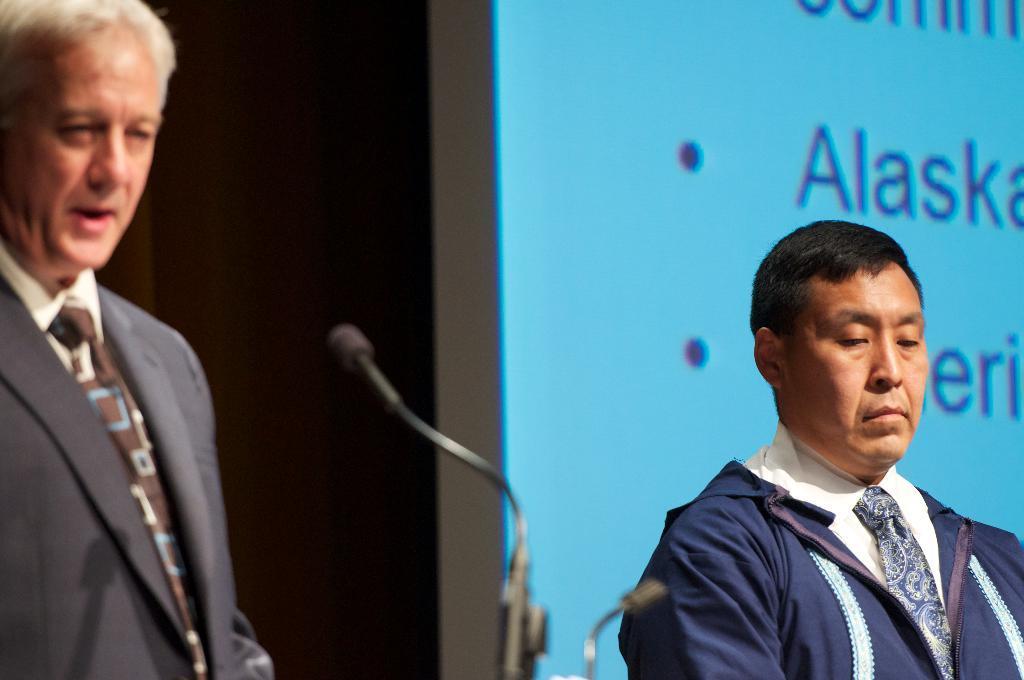Could you give a brief overview of what you see in this image? In this image, we can see persons wearing clothes. There are mics at the bottom of the image. There is a screen on the right side of the image. 